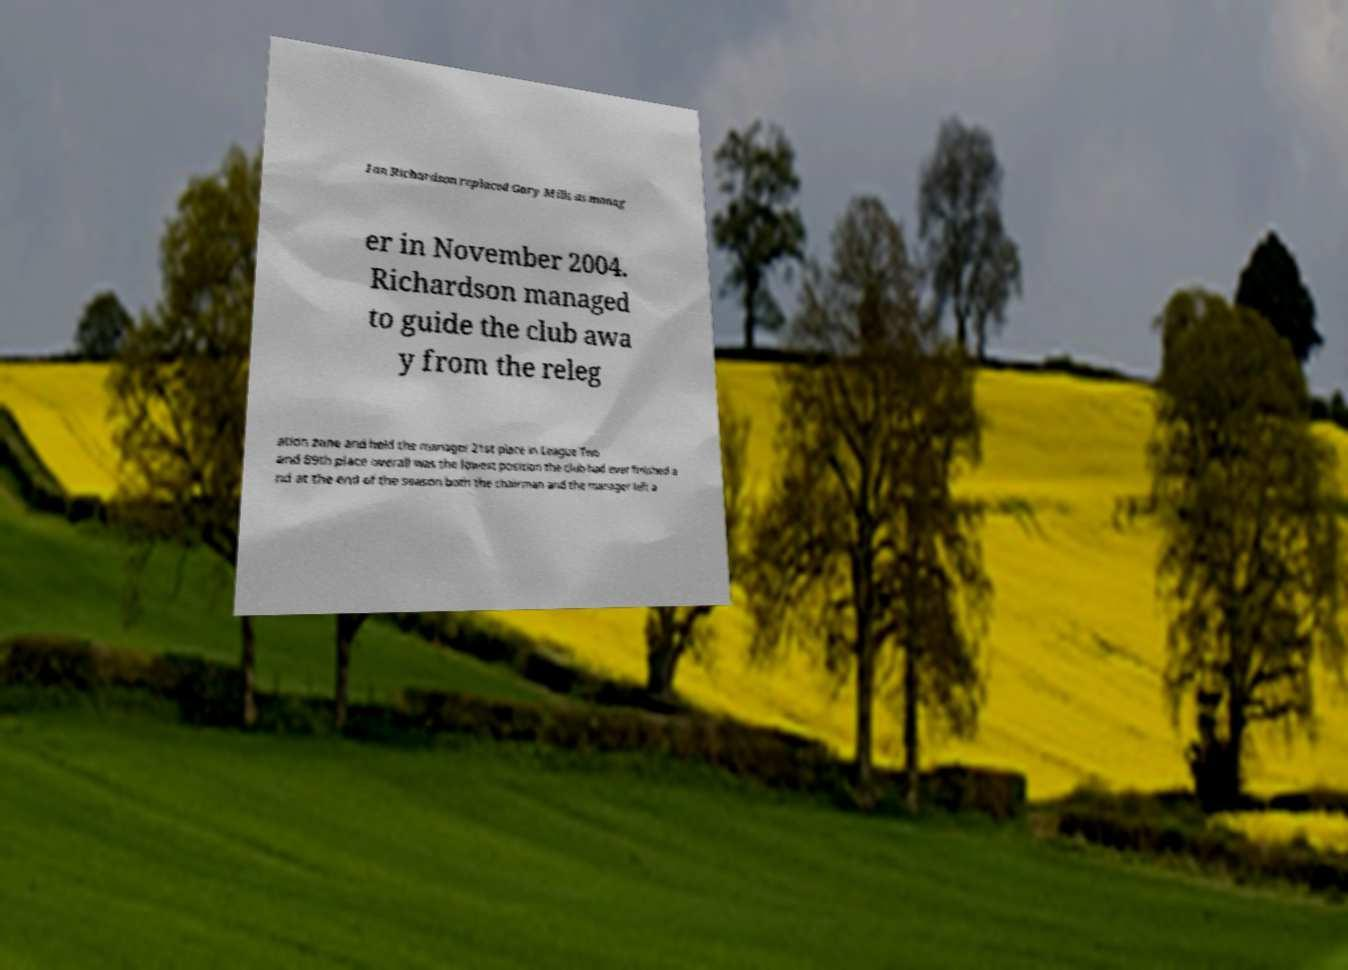For documentation purposes, I need the text within this image transcribed. Could you provide that? Ian Richardson replaced Gary Mills as manag er in November 2004. Richardson managed to guide the club awa y from the releg ation zone and held the manager 21st place in League Two and 89th place overall was the lowest position the club had ever finished a nd at the end of the season both the chairman and the manager left a 